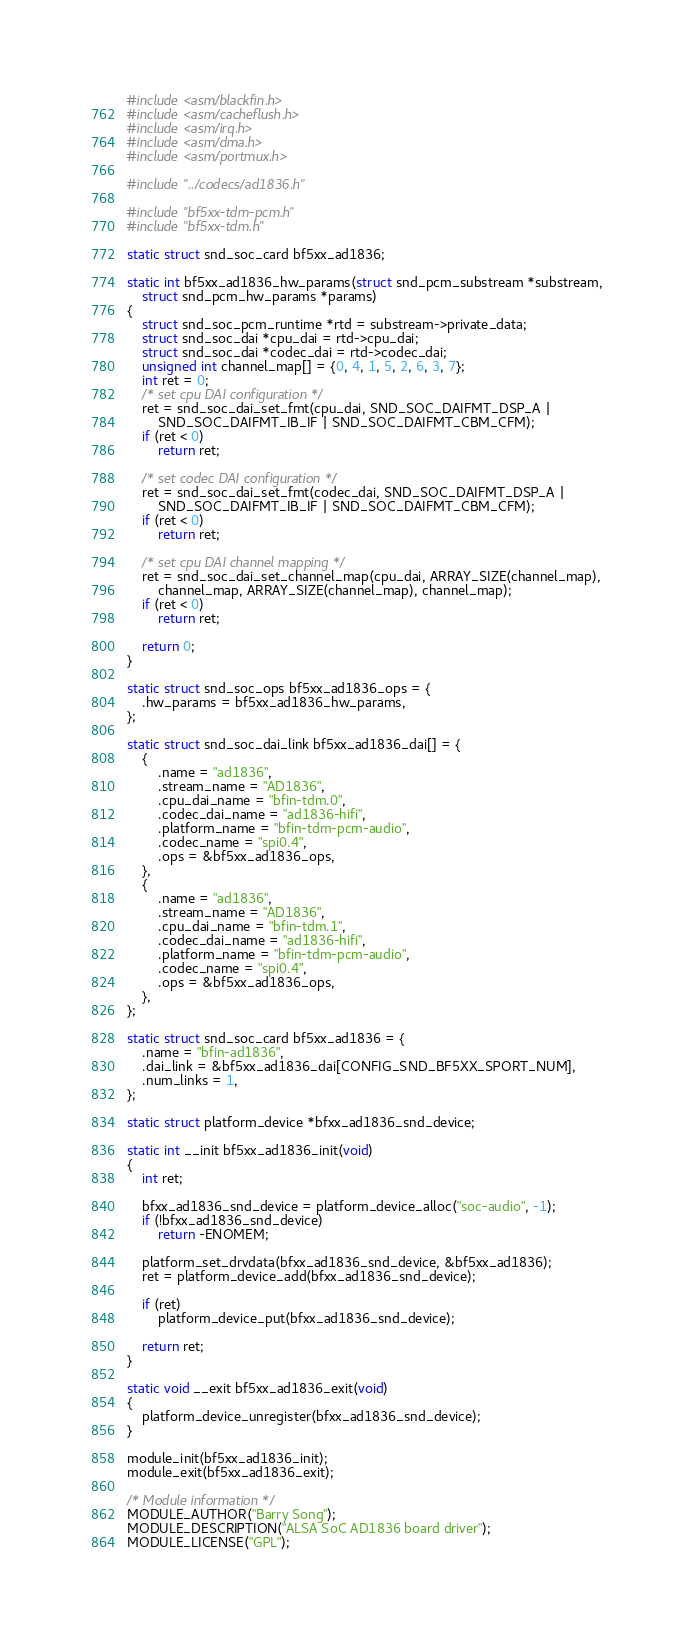Convert code to text. <code><loc_0><loc_0><loc_500><loc_500><_C_>#include <asm/blackfin.h>
#include <asm/cacheflush.h>
#include <asm/irq.h>
#include <asm/dma.h>
#include <asm/portmux.h>

#include "../codecs/ad1836.h"

#include "bf5xx-tdm-pcm.h"
#include "bf5xx-tdm.h"

static struct snd_soc_card bf5xx_ad1836;

static int bf5xx_ad1836_hw_params(struct snd_pcm_substream *substream,
	struct snd_pcm_hw_params *params)
{
	struct snd_soc_pcm_runtime *rtd = substream->private_data;
	struct snd_soc_dai *cpu_dai = rtd->cpu_dai;
	struct snd_soc_dai *codec_dai = rtd->codec_dai;
	unsigned int channel_map[] = {0, 4, 1, 5, 2, 6, 3, 7};
	int ret = 0;
	/* set cpu DAI configuration */
	ret = snd_soc_dai_set_fmt(cpu_dai, SND_SOC_DAIFMT_DSP_A |
		SND_SOC_DAIFMT_IB_IF | SND_SOC_DAIFMT_CBM_CFM);
	if (ret < 0)
		return ret;

	/* set codec DAI configuration */
	ret = snd_soc_dai_set_fmt(codec_dai, SND_SOC_DAIFMT_DSP_A |
		SND_SOC_DAIFMT_IB_IF | SND_SOC_DAIFMT_CBM_CFM);
	if (ret < 0)
		return ret;

	/* set cpu DAI channel mapping */
	ret = snd_soc_dai_set_channel_map(cpu_dai, ARRAY_SIZE(channel_map),
		channel_map, ARRAY_SIZE(channel_map), channel_map);
	if (ret < 0)
		return ret;

	return 0;
}

static struct snd_soc_ops bf5xx_ad1836_ops = {
	.hw_params = bf5xx_ad1836_hw_params,
};

static struct snd_soc_dai_link bf5xx_ad1836_dai[] = {
	{
		.name = "ad1836",
		.stream_name = "AD1836",
		.cpu_dai_name = "bfin-tdm.0",
		.codec_dai_name = "ad1836-hifi",
		.platform_name = "bfin-tdm-pcm-audio",
		.codec_name = "spi0.4",
		.ops = &bf5xx_ad1836_ops,
	},
	{
		.name = "ad1836",
		.stream_name = "AD1836",
		.cpu_dai_name = "bfin-tdm.1",
		.codec_dai_name = "ad1836-hifi",
		.platform_name = "bfin-tdm-pcm-audio",
		.codec_name = "spi0.4",
		.ops = &bf5xx_ad1836_ops,
	},
};

static struct snd_soc_card bf5xx_ad1836 = {
	.name = "bfin-ad1836",
	.dai_link = &bf5xx_ad1836_dai[CONFIG_SND_BF5XX_SPORT_NUM],
	.num_links = 1,
};

static struct platform_device *bfxx_ad1836_snd_device;

static int __init bf5xx_ad1836_init(void)
{
	int ret;

	bfxx_ad1836_snd_device = platform_device_alloc("soc-audio", -1);
	if (!bfxx_ad1836_snd_device)
		return -ENOMEM;

	platform_set_drvdata(bfxx_ad1836_snd_device, &bf5xx_ad1836);
	ret = platform_device_add(bfxx_ad1836_snd_device);

	if (ret)
		platform_device_put(bfxx_ad1836_snd_device);

	return ret;
}

static void __exit bf5xx_ad1836_exit(void)
{
	platform_device_unregister(bfxx_ad1836_snd_device);
}

module_init(bf5xx_ad1836_init);
module_exit(bf5xx_ad1836_exit);

/* Module information */
MODULE_AUTHOR("Barry Song");
MODULE_DESCRIPTION("ALSA SoC AD1836 board driver");
MODULE_LICENSE("GPL");

</code> 